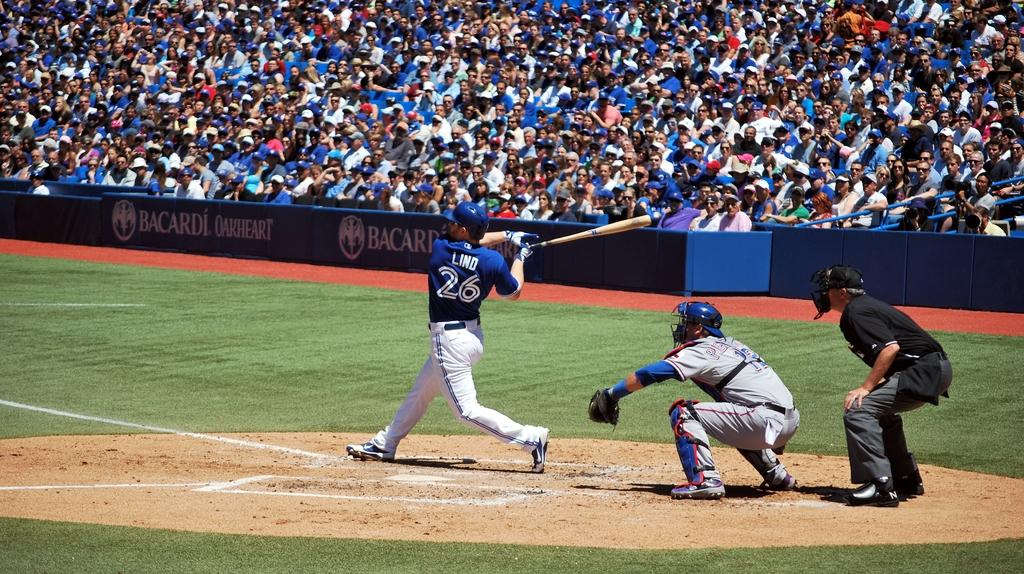<image>
Relay a brief, clear account of the picture shown. A batter with the number 26 and word Lind on the back of his shirt is swinging his bat. 